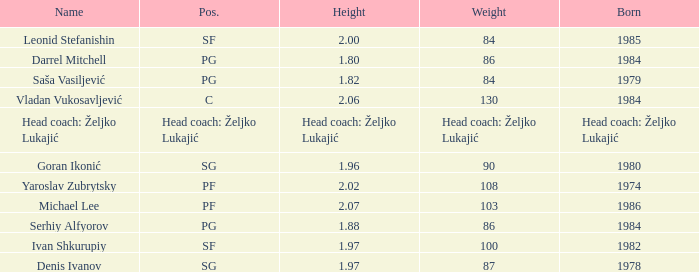What was the weight of Serhiy Alfyorov? 86.0. 